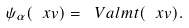<formula> <loc_0><loc_0><loc_500><loc_500>\psi _ { \alpha } ( \ x v ) = \ V a l m t ( \ x v ) .</formula> 